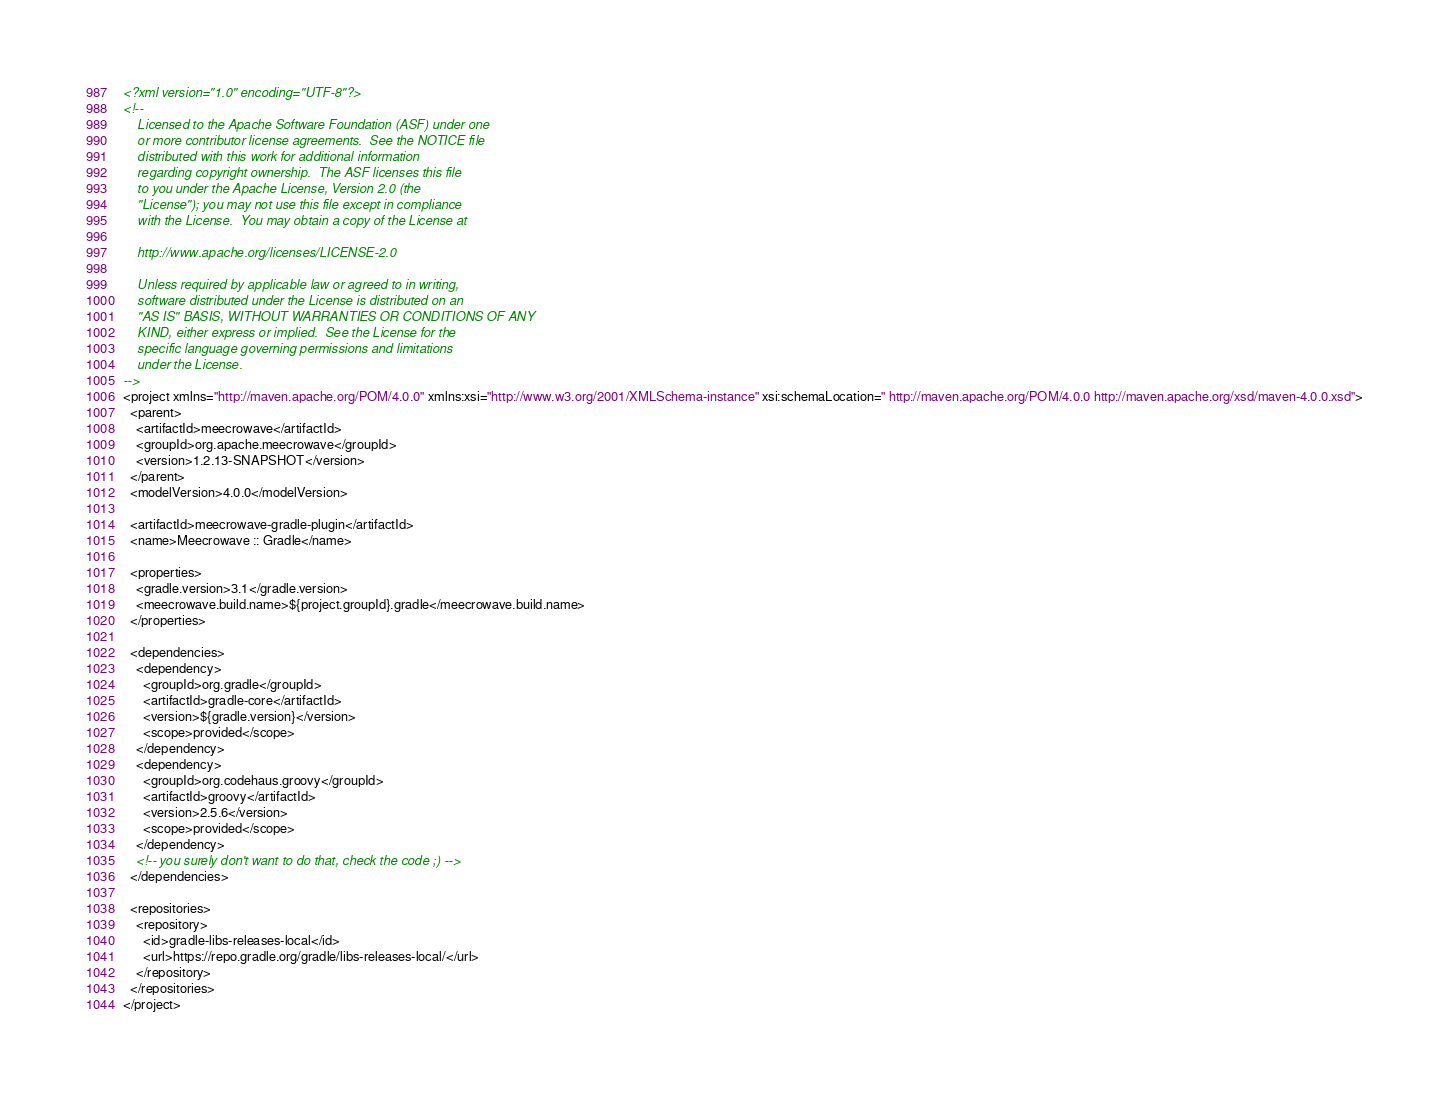Convert code to text. <code><loc_0><loc_0><loc_500><loc_500><_XML_><?xml version="1.0" encoding="UTF-8"?>
<!--
    Licensed to the Apache Software Foundation (ASF) under one
    or more contributor license agreements.  See the NOTICE file
    distributed with this work for additional information
    regarding copyright ownership.  The ASF licenses this file
    to you under the Apache License, Version 2.0 (the
    "License"); you may not use this file except in compliance
    with the License.  You may obtain a copy of the License at

    http://www.apache.org/licenses/LICENSE-2.0

    Unless required by applicable law or agreed to in writing,
    software distributed under the License is distributed on an
    "AS IS" BASIS, WITHOUT WARRANTIES OR CONDITIONS OF ANY
    KIND, either express or implied.  See the License for the
    specific language governing permissions and limitations
    under the License.
-->
<project xmlns="http://maven.apache.org/POM/4.0.0" xmlns:xsi="http://www.w3.org/2001/XMLSchema-instance" xsi:schemaLocation=" http://maven.apache.org/POM/4.0.0 http://maven.apache.org/xsd/maven-4.0.0.xsd">
  <parent>
    <artifactId>meecrowave</artifactId>
    <groupId>org.apache.meecrowave</groupId>
    <version>1.2.13-SNAPSHOT</version>
  </parent>
  <modelVersion>4.0.0</modelVersion>

  <artifactId>meecrowave-gradle-plugin</artifactId>
  <name>Meecrowave :: Gradle</name>

  <properties>
    <gradle.version>3.1</gradle.version>
    <meecrowave.build.name>${project.groupId}.gradle</meecrowave.build.name>
  </properties>

  <dependencies>
    <dependency>
      <groupId>org.gradle</groupId>
      <artifactId>gradle-core</artifactId>
      <version>${gradle.version}</version>
      <scope>provided</scope>
    </dependency>
    <dependency>
      <groupId>org.codehaus.groovy</groupId>
      <artifactId>groovy</artifactId>
      <version>2.5.6</version>
      <scope>provided</scope>
    </dependency>
    <!-- you surely don't want to do that, check the code ;) -->
  </dependencies>

  <repositories>
    <repository>
      <id>gradle-libs-releases-local</id>
      <url>https://repo.gradle.org/gradle/libs-releases-local/</url>
    </repository>
  </repositories>
</project>
</code> 